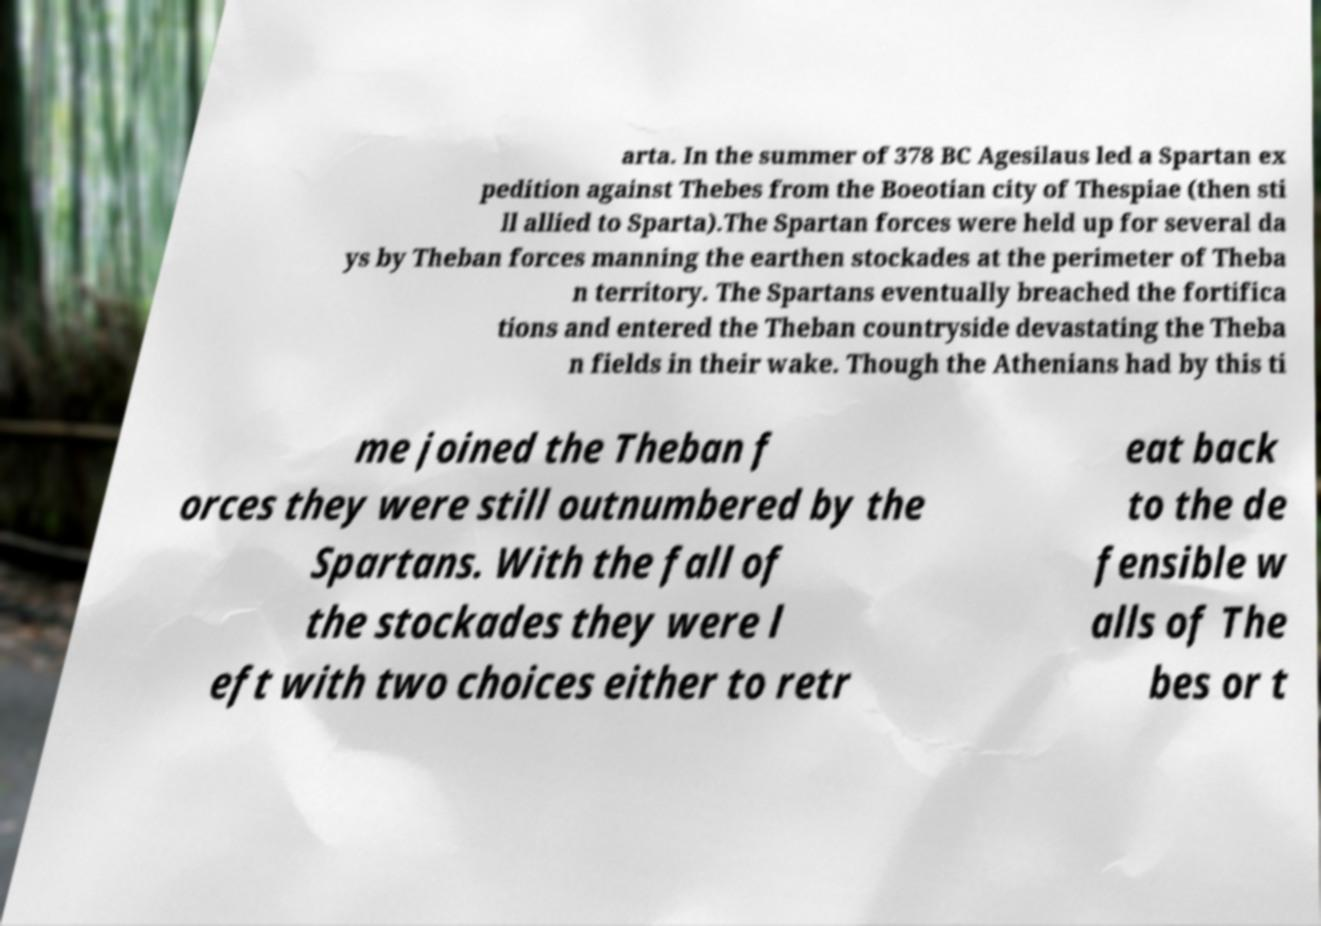Could you extract and type out the text from this image? arta. In the summer of 378 BC Agesilaus led a Spartan ex pedition against Thebes from the Boeotian city of Thespiae (then sti ll allied to Sparta).The Spartan forces were held up for several da ys by Theban forces manning the earthen stockades at the perimeter of Theba n territory. The Spartans eventually breached the fortifica tions and entered the Theban countryside devastating the Theba n fields in their wake. Though the Athenians had by this ti me joined the Theban f orces they were still outnumbered by the Spartans. With the fall of the stockades they were l eft with two choices either to retr eat back to the de fensible w alls of The bes or t 